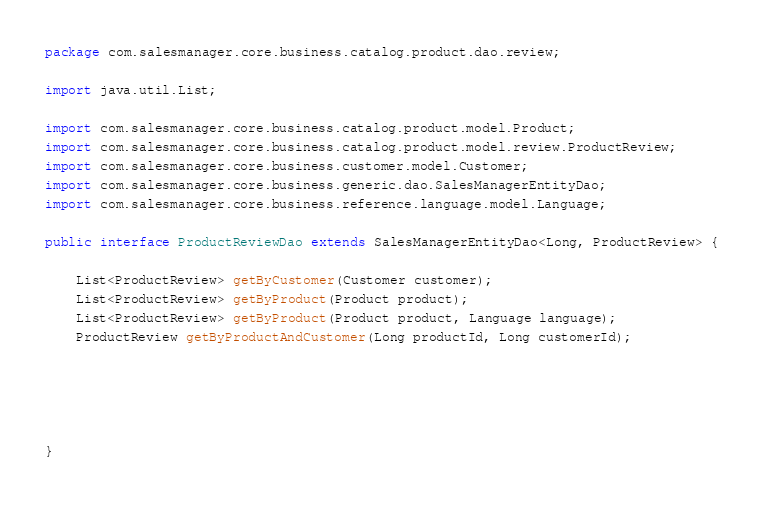<code> <loc_0><loc_0><loc_500><loc_500><_Java_>package com.salesmanager.core.business.catalog.product.dao.review;

import java.util.List;

import com.salesmanager.core.business.catalog.product.model.Product;
import com.salesmanager.core.business.catalog.product.model.review.ProductReview;
import com.salesmanager.core.business.customer.model.Customer;
import com.salesmanager.core.business.generic.dao.SalesManagerEntityDao;
import com.salesmanager.core.business.reference.language.model.Language;

public interface ProductReviewDao extends SalesManagerEntityDao<Long, ProductReview> {

	List<ProductReview> getByCustomer(Customer customer);
	List<ProductReview> getByProduct(Product product);
	List<ProductReview> getByProduct(Product product, Language language);
	ProductReview getByProductAndCustomer(Long productId, Long customerId);





}
</code> 